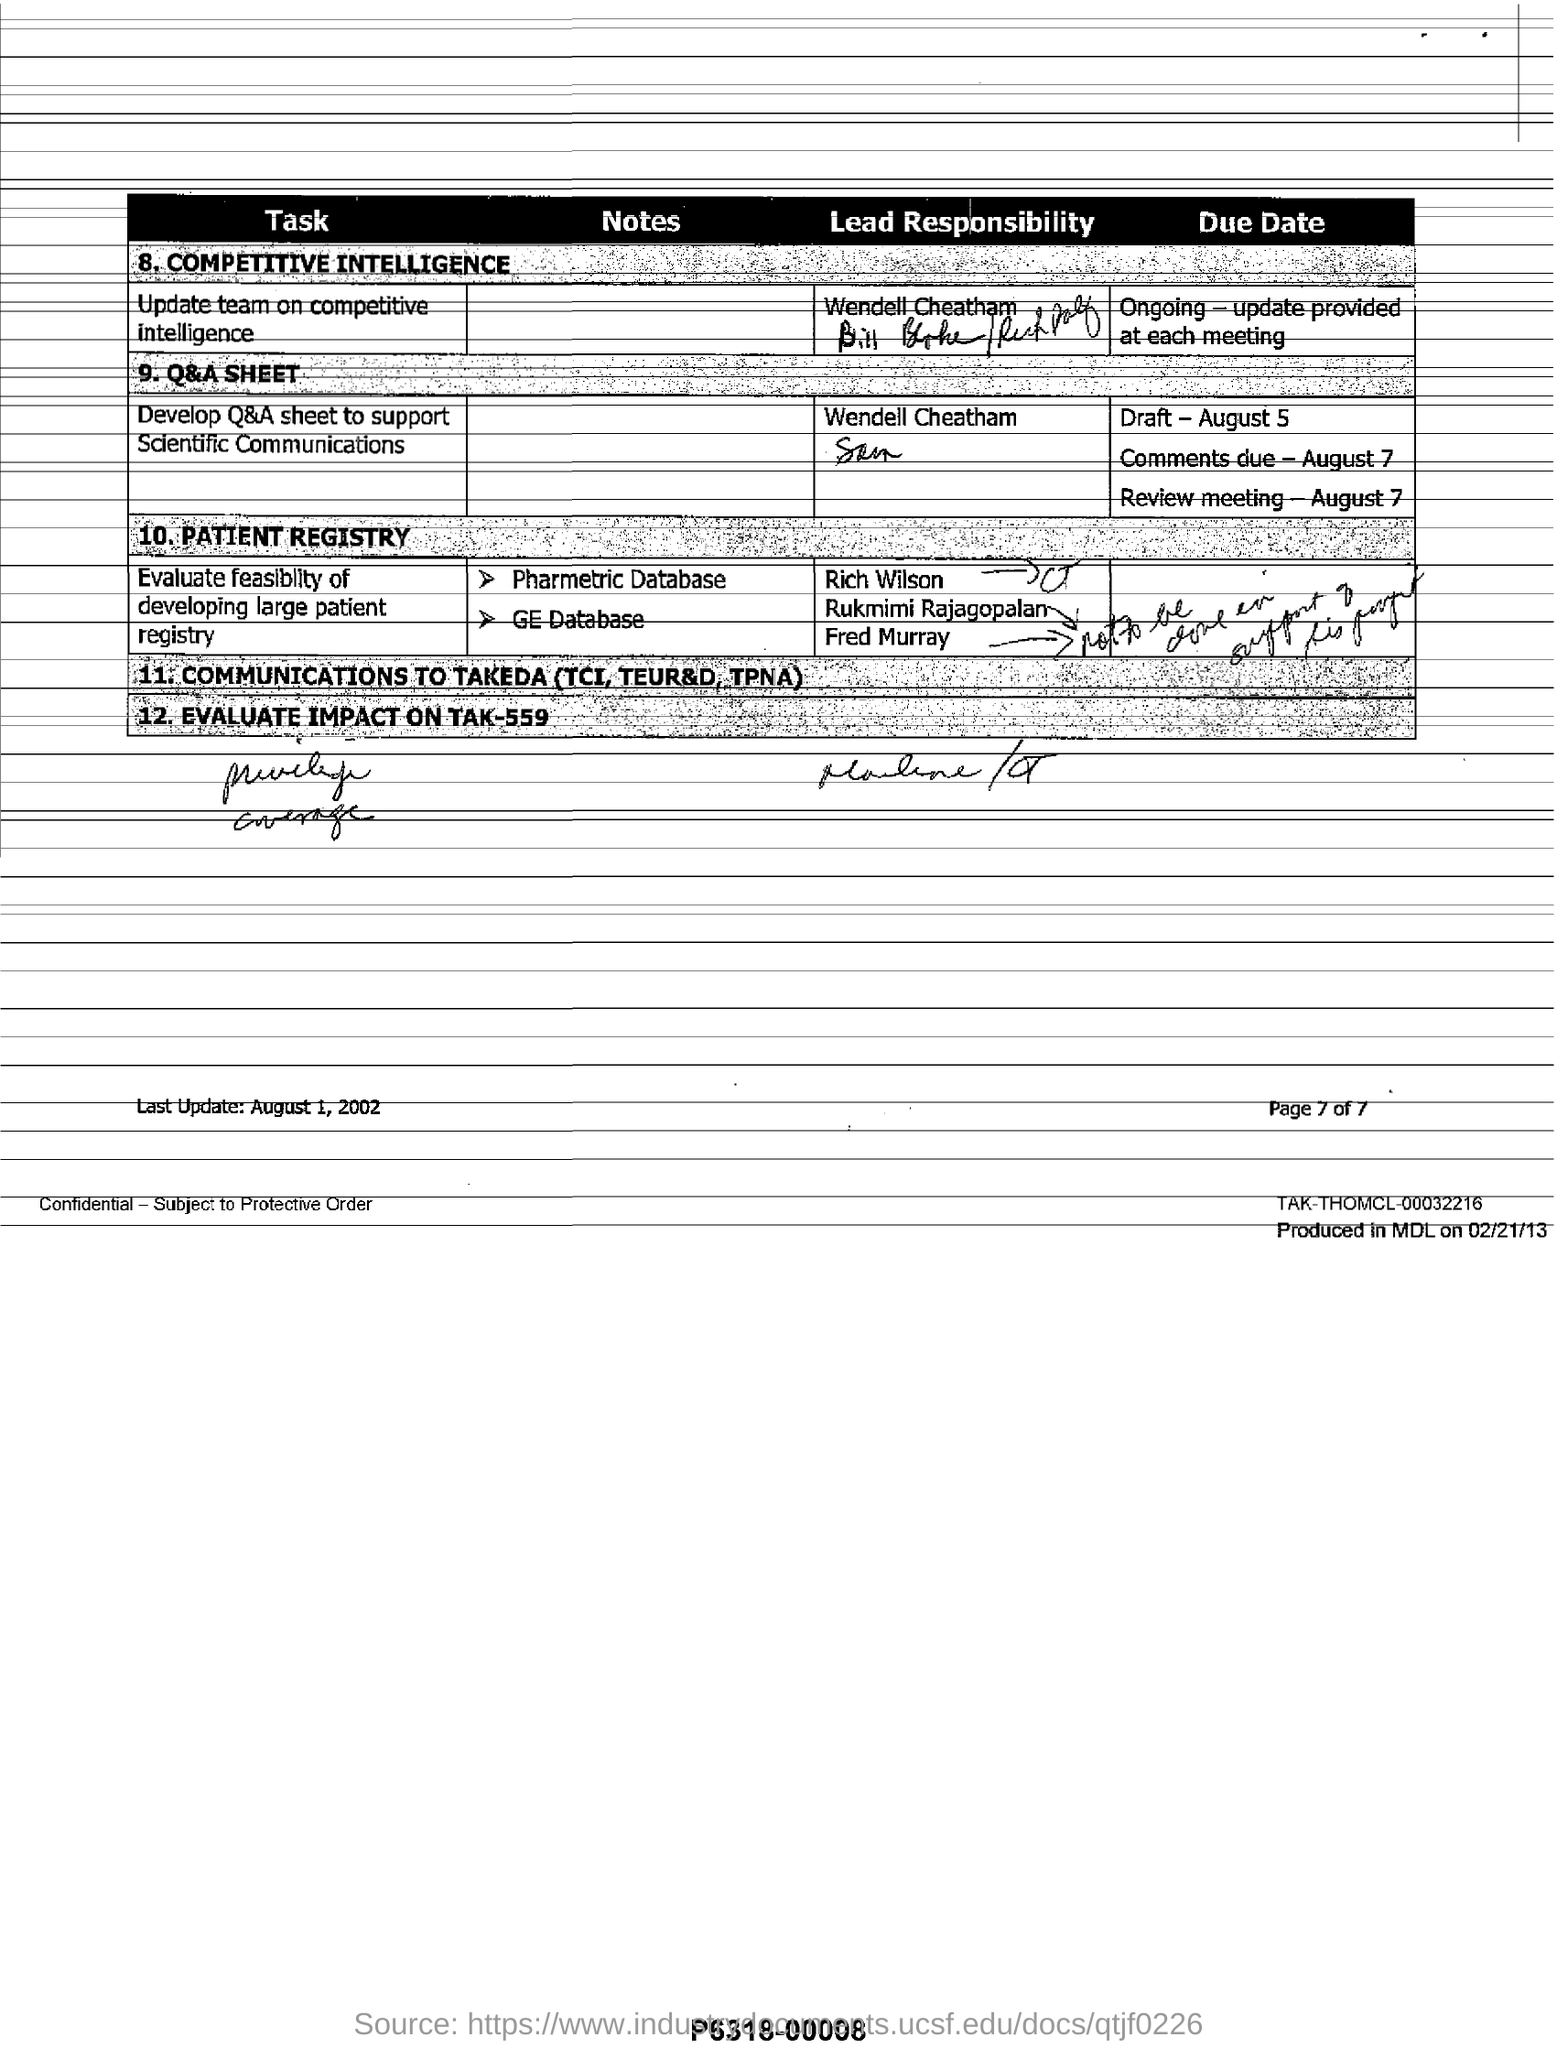When was this document last updated?
Make the answer very short. August 1, 2002. What is the last point in the table?
Provide a short and direct response. Evaluate Impact on Tak-559. What is the Draft's Due Date?
Offer a very short reply. August 5. 